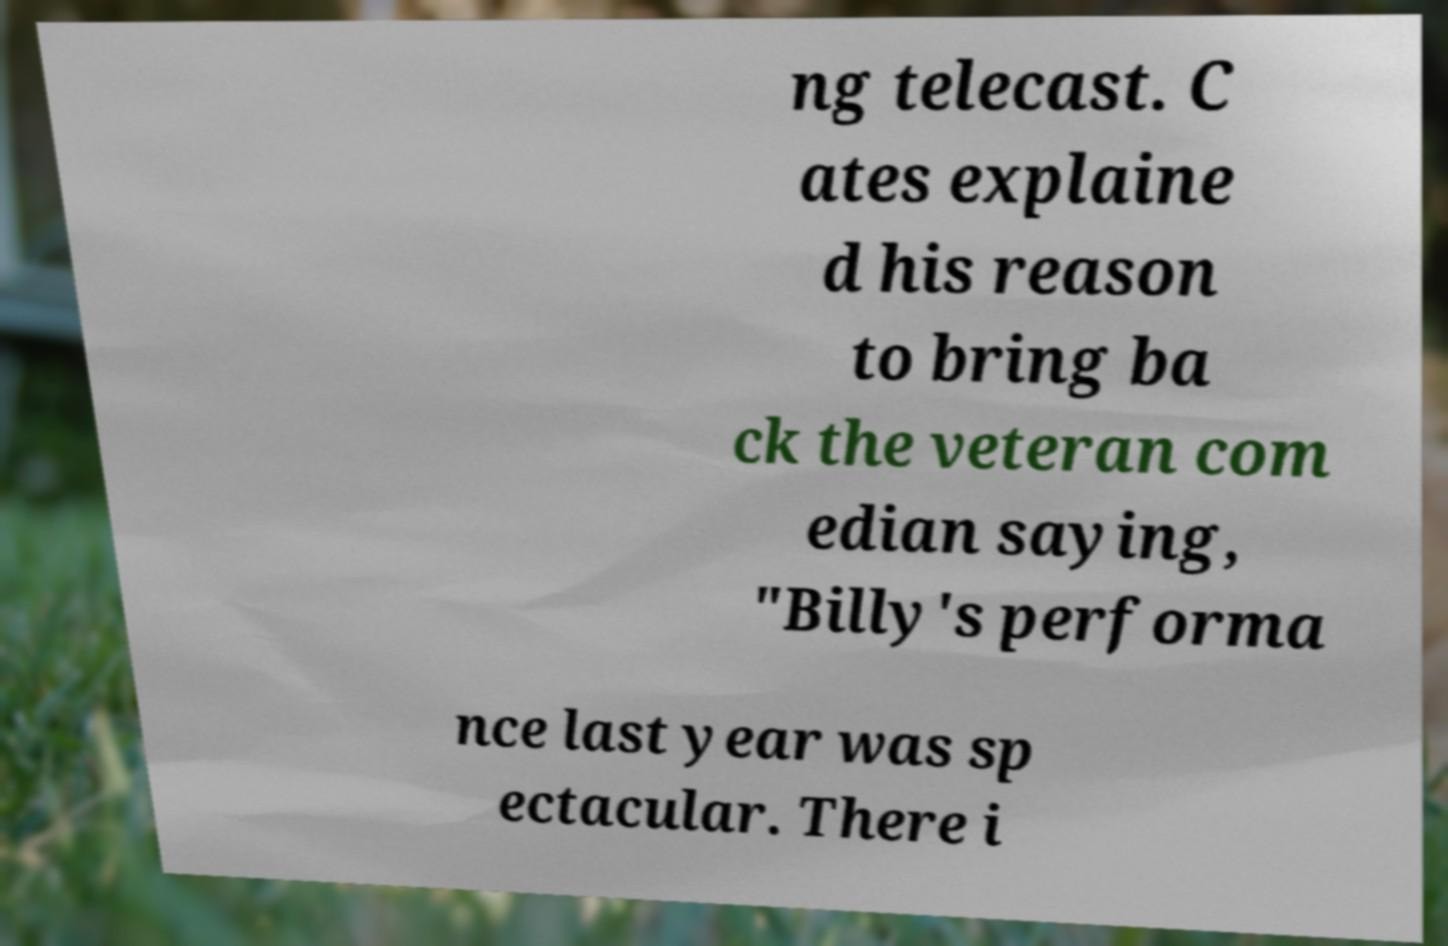I need the written content from this picture converted into text. Can you do that? ng telecast. C ates explaine d his reason to bring ba ck the veteran com edian saying, "Billy's performa nce last year was sp ectacular. There i 